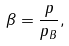Convert formula to latex. <formula><loc_0><loc_0><loc_500><loc_500>\beta = \frac { p } { p _ { B } } ,</formula> 